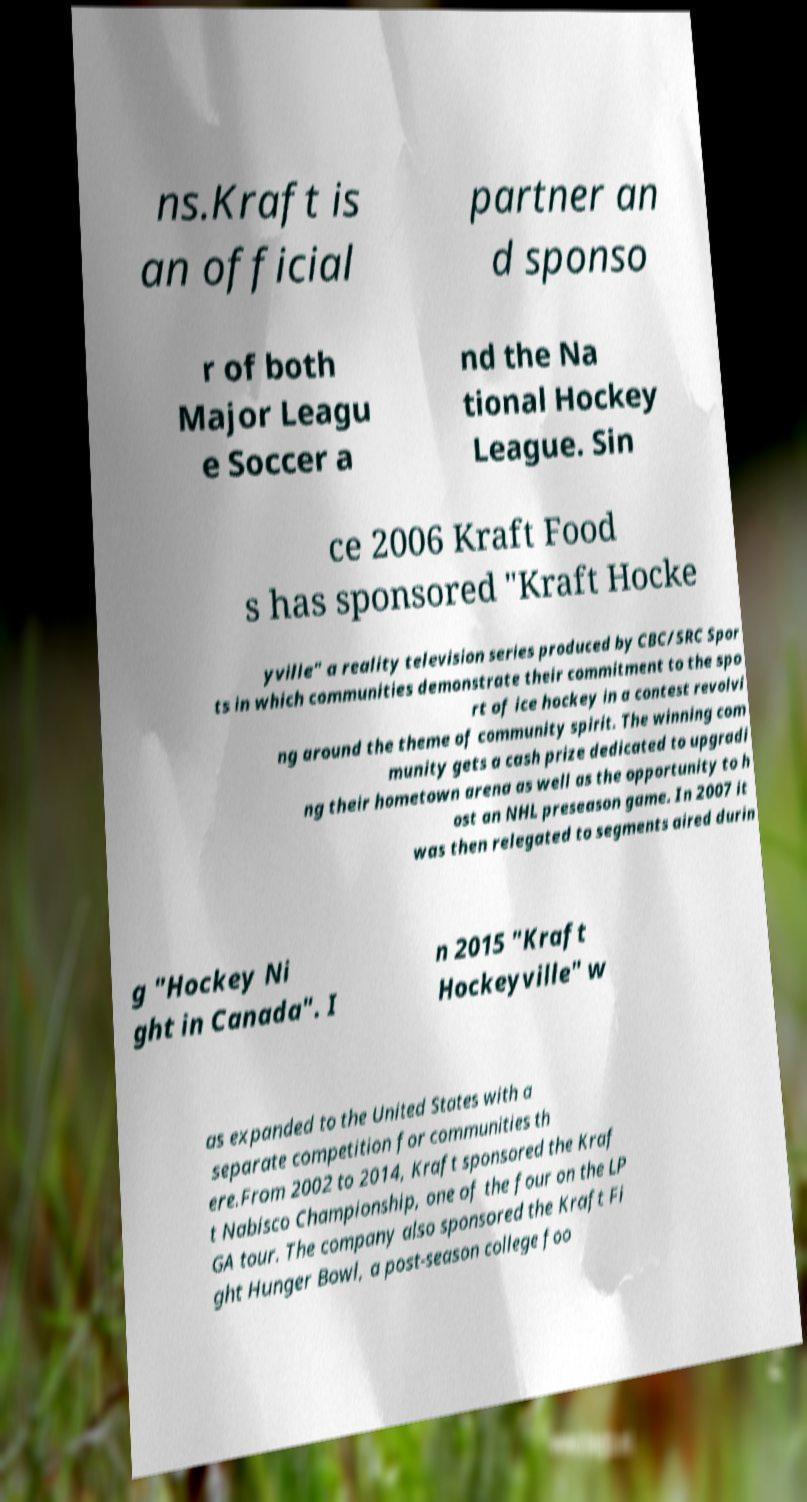There's text embedded in this image that I need extracted. Can you transcribe it verbatim? ns.Kraft is an official partner an d sponso r of both Major Leagu e Soccer a nd the Na tional Hockey League. Sin ce 2006 Kraft Food s has sponsored "Kraft Hocke yville" a reality television series produced by CBC/SRC Spor ts in which communities demonstrate their commitment to the spo rt of ice hockey in a contest revolvi ng around the theme of community spirit. The winning com munity gets a cash prize dedicated to upgradi ng their hometown arena as well as the opportunity to h ost an NHL preseason game. In 2007 it was then relegated to segments aired durin g "Hockey Ni ght in Canada". I n 2015 "Kraft Hockeyville" w as expanded to the United States with a separate competition for communities th ere.From 2002 to 2014, Kraft sponsored the Kraf t Nabisco Championship, one of the four on the LP GA tour. The company also sponsored the Kraft Fi ght Hunger Bowl, a post-season college foo 